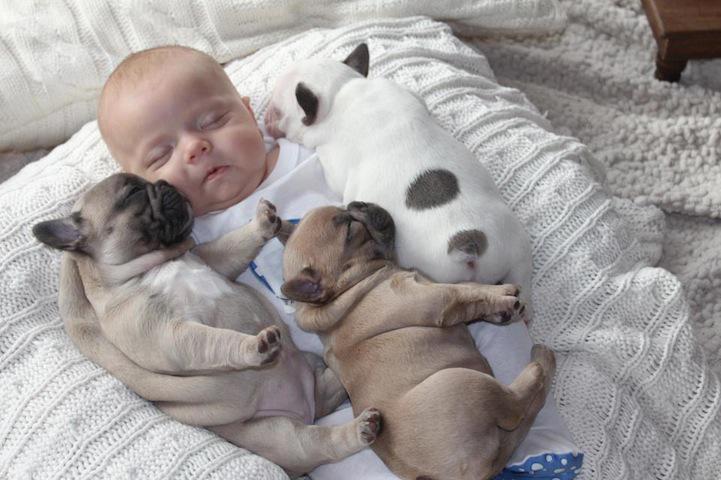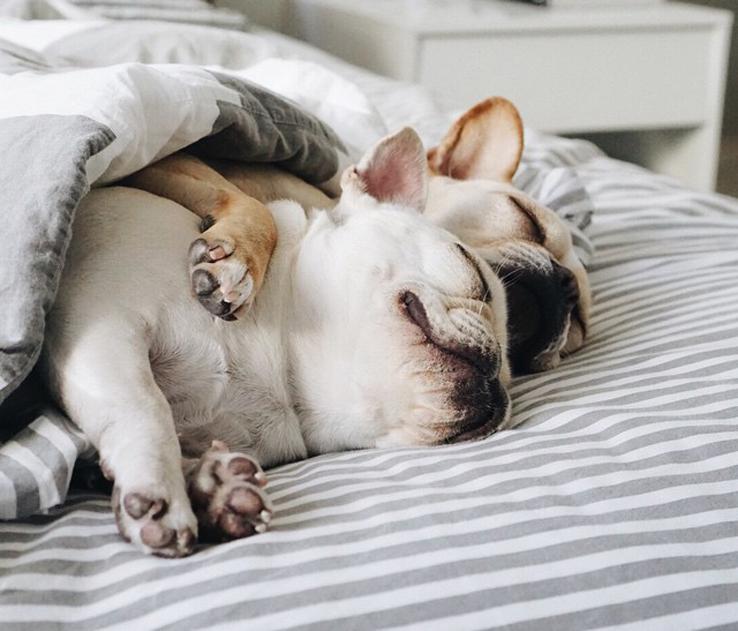The first image is the image on the left, the second image is the image on the right. Assess this claim about the two images: "The right image contains at least three dogs.". Correct or not? Answer yes or no. No. 